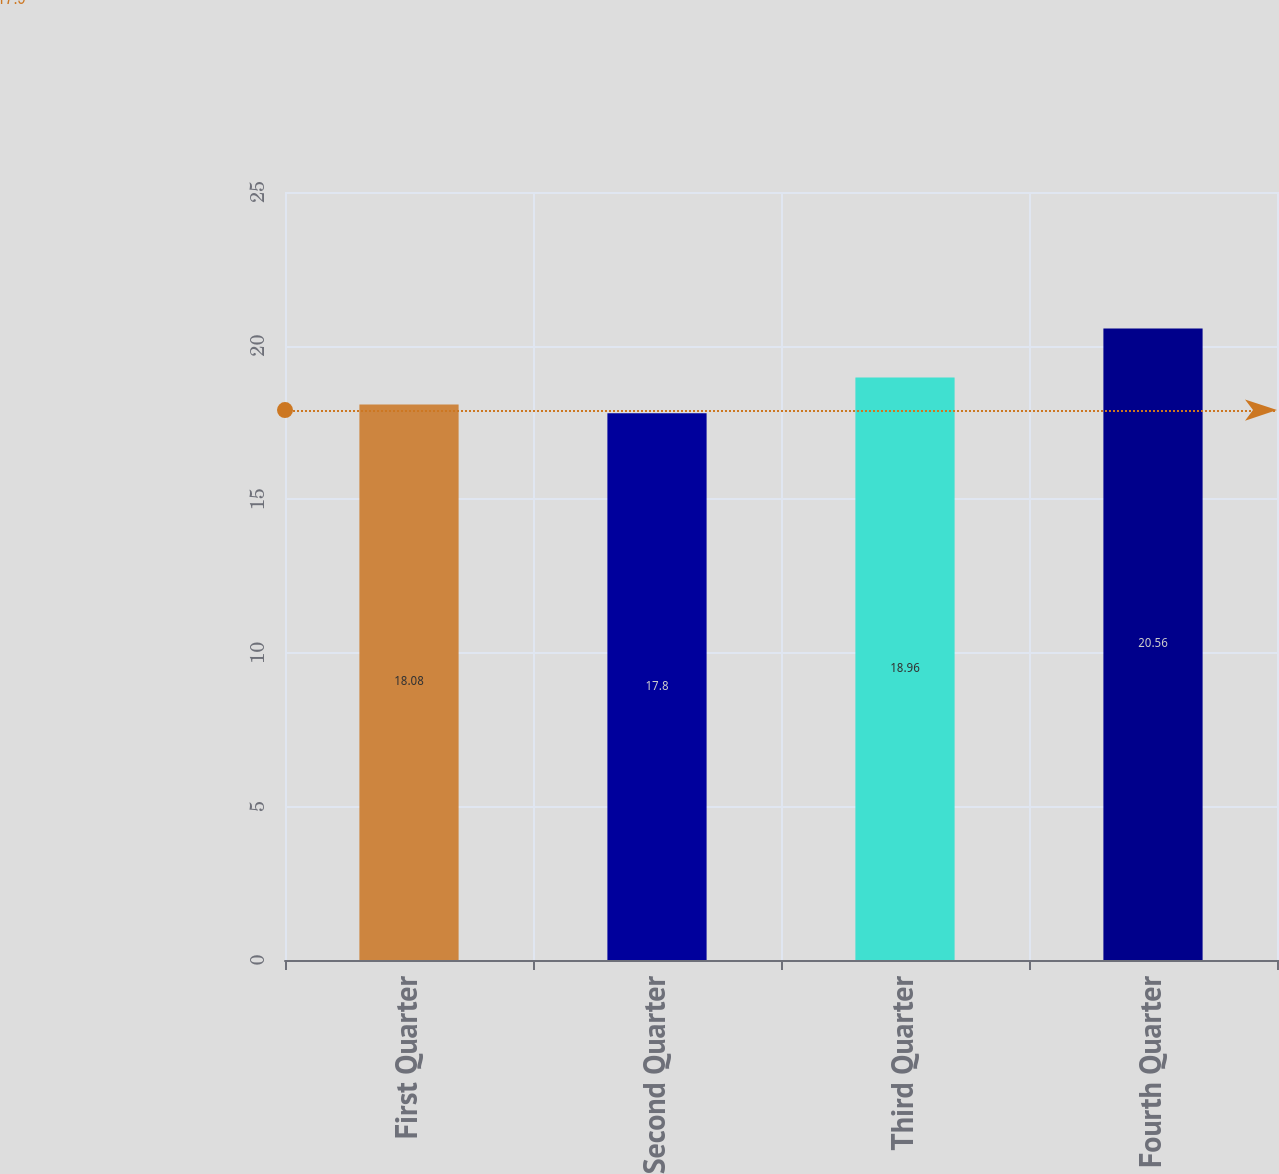Convert chart. <chart><loc_0><loc_0><loc_500><loc_500><bar_chart><fcel>First Quarter<fcel>Second Quarter<fcel>Third Quarter<fcel>Fourth Quarter<nl><fcel>18.08<fcel>17.8<fcel>18.96<fcel>20.56<nl></chart> 